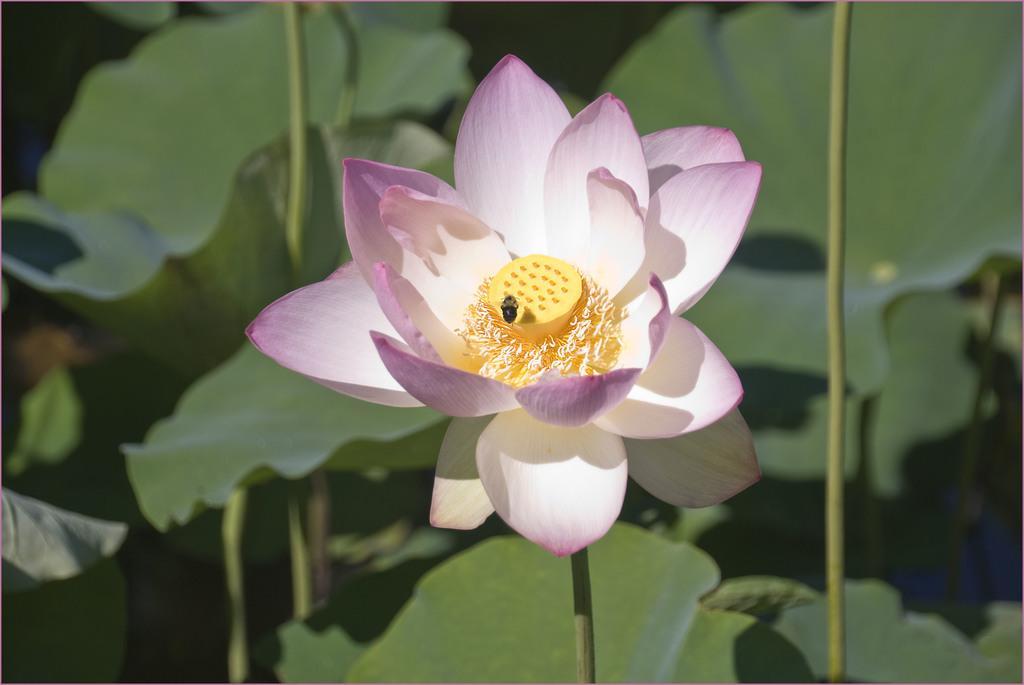Please provide a concise description of this image. It is a beautiful lotus flower there is a bee on it. 